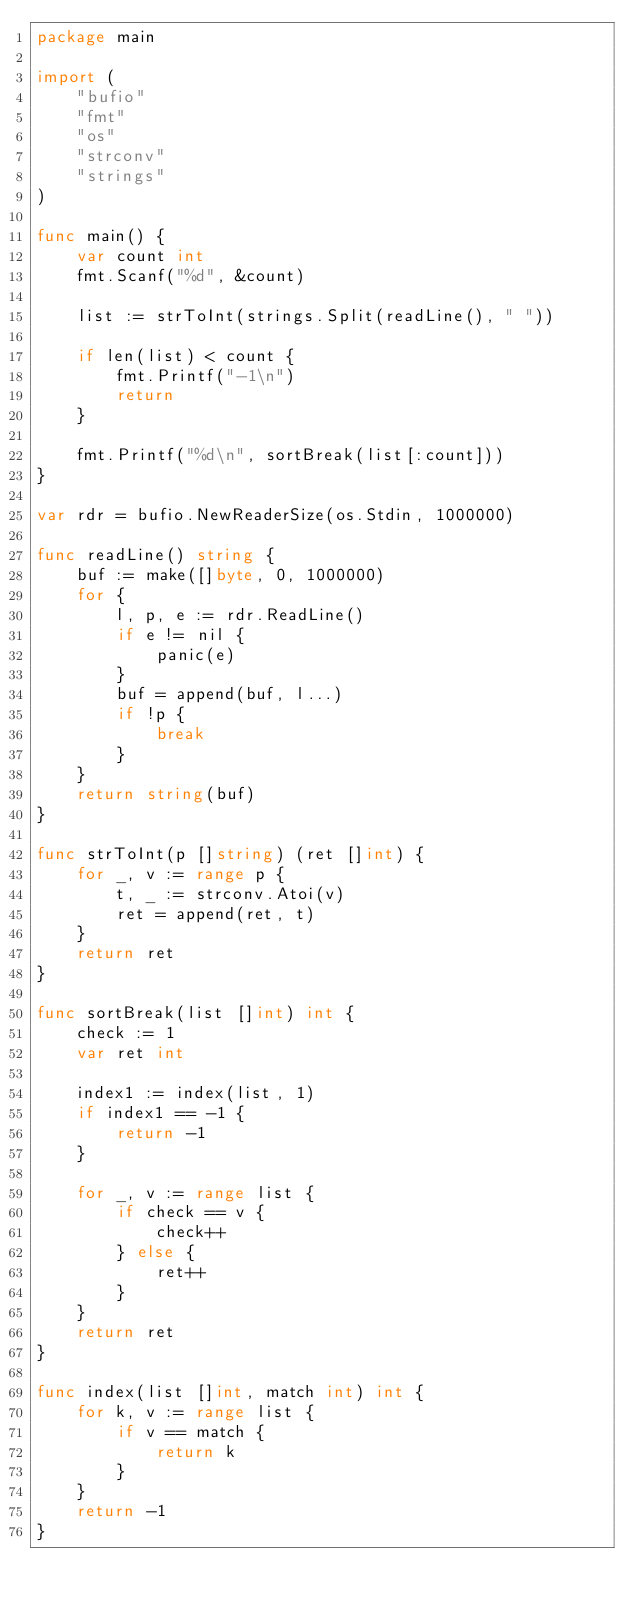<code> <loc_0><loc_0><loc_500><loc_500><_Go_>package main

import (
	"bufio"
	"fmt"
	"os"
	"strconv"
	"strings"
)

func main() {
	var count int
	fmt.Scanf("%d", &count)

	list := strToInt(strings.Split(readLine(), " "))

	if len(list) < count {
		fmt.Printf("-1\n")
		return
	}

	fmt.Printf("%d\n", sortBreak(list[:count]))
}

var rdr = bufio.NewReaderSize(os.Stdin, 1000000)

func readLine() string {
	buf := make([]byte, 0, 1000000)
	for {
		l, p, e := rdr.ReadLine()
		if e != nil {
			panic(e)
		}
		buf = append(buf, l...)
		if !p {
			break
		}
	}
	return string(buf)
}

func strToInt(p []string) (ret []int) {
	for _, v := range p {
		t, _ := strconv.Atoi(v)
		ret = append(ret, t)
	}
	return ret
}

func sortBreak(list []int) int {
	check := 1
	var ret int

	index1 := index(list, 1)
	if index1 == -1 {
		return -1
	}

	for _, v := range list {
		if check == v {
			check++
		} else {
			ret++
		}
	}
	return ret
}

func index(list []int, match int) int {
	for k, v := range list {
		if v == match {
			return k
		}
	}
	return -1
}
</code> 